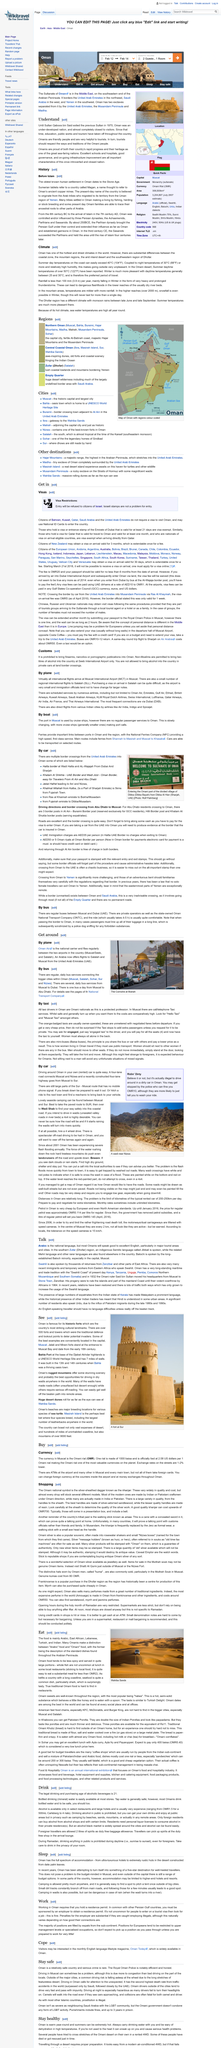Draw attention to some important aspects in this diagram. Alcoholic beverages are typically found in large hotels and select restaurants. The capital of Oman is Muscat, as stated in the sentence. Driving on the roads outside of the major cities in Oman can pose a significant driving risk, particularly due to the long stretches of featureless desert landscapes that can cause drivers to become drowsy and prone to falling asleep at the wheel. Yes, there are several daily bus services from Muscat to Dubai. There is one bus that leaves Muscat daily for Abu Dhabi. 